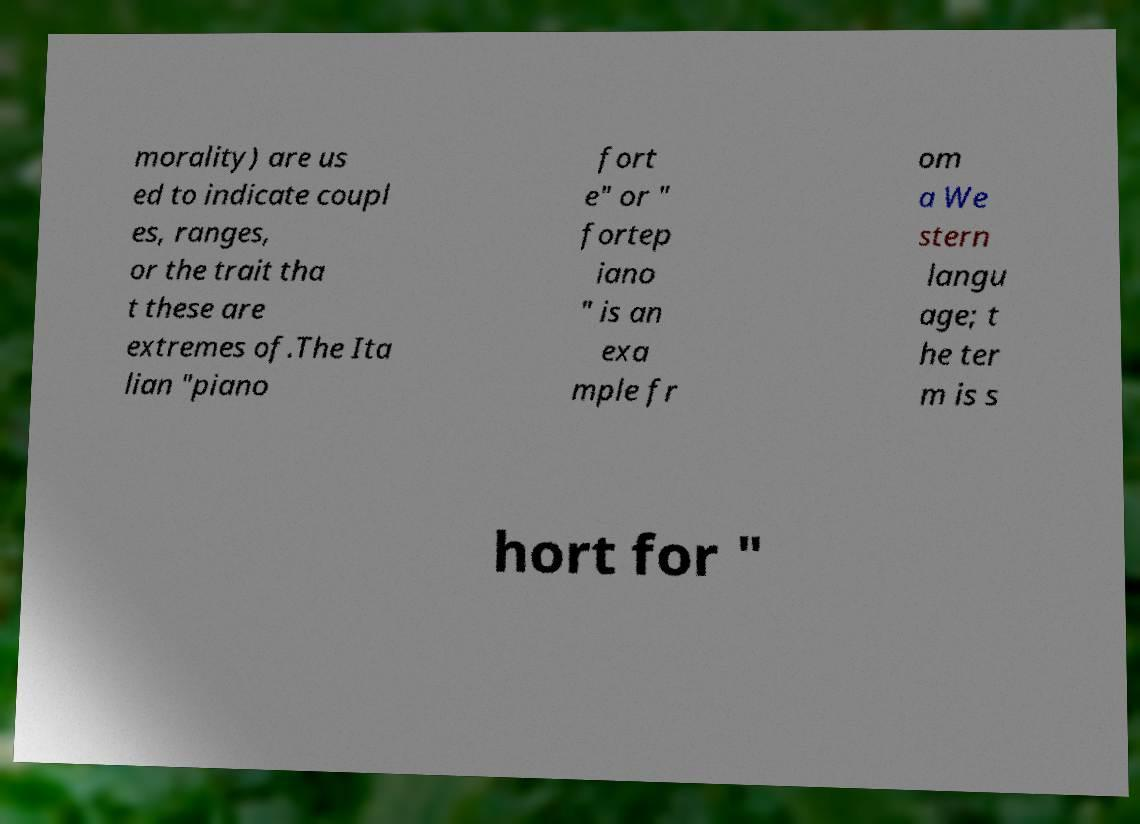Could you extract and type out the text from this image? morality) are us ed to indicate coupl es, ranges, or the trait tha t these are extremes of.The Ita lian "piano fort e" or " fortep iano " is an exa mple fr om a We stern langu age; t he ter m is s hort for " 